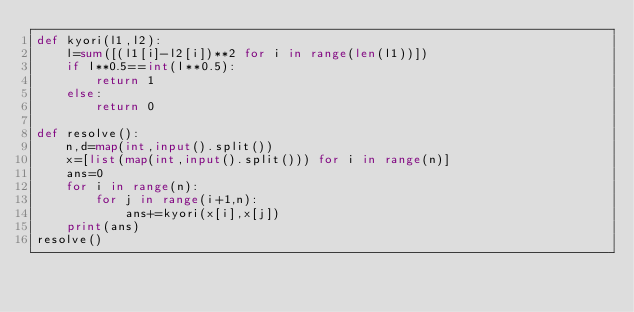<code> <loc_0><loc_0><loc_500><loc_500><_Python_>def kyori(l1,l2):
    l=sum([(l1[i]-l2[i])**2 for i in range(len(l1))])
    if l**0.5==int(l**0.5):
        return 1
    else:
        return 0

def resolve():
    n,d=map(int,input().split())
    x=[list(map(int,input().split())) for i in range(n)]
    ans=0
    for i in range(n):
        for j in range(i+1,n):
            ans+=kyori(x[i],x[j])
    print(ans)
resolve()</code> 